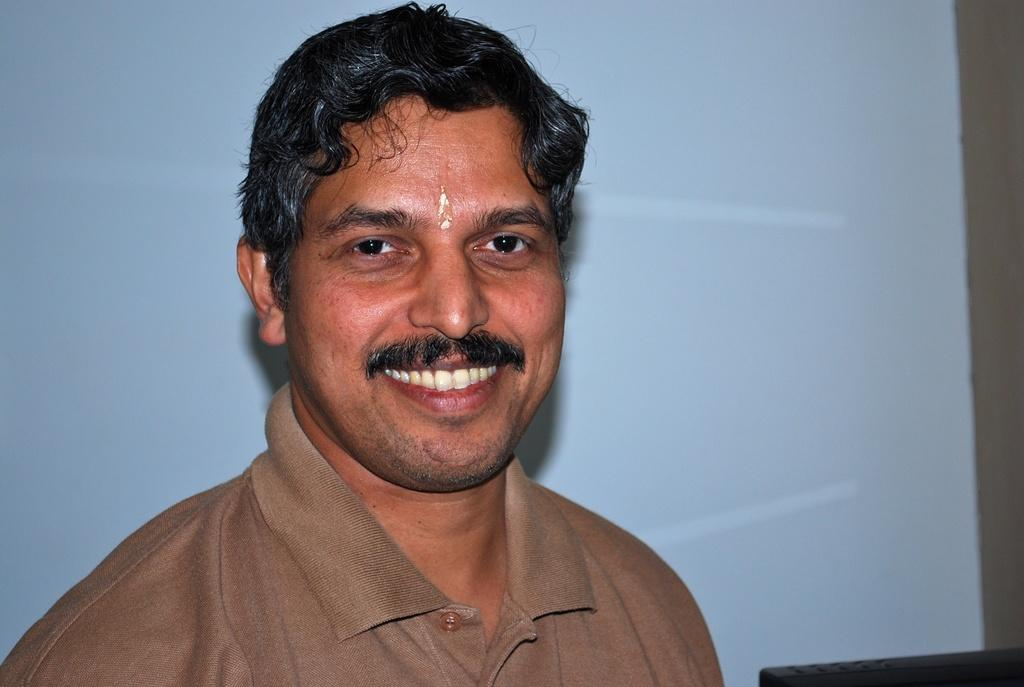Who or what is the main subject of the image? There is a person in the image. What is the person wearing? The person is wearing a brown color dress. Can you describe the background of the image? The background of the image is blue and ash colored. What year is depicted in the image? The image does not depict a specific year; it is a photograph of a person wearing a brown dress in front of a blue and ash colored background. 